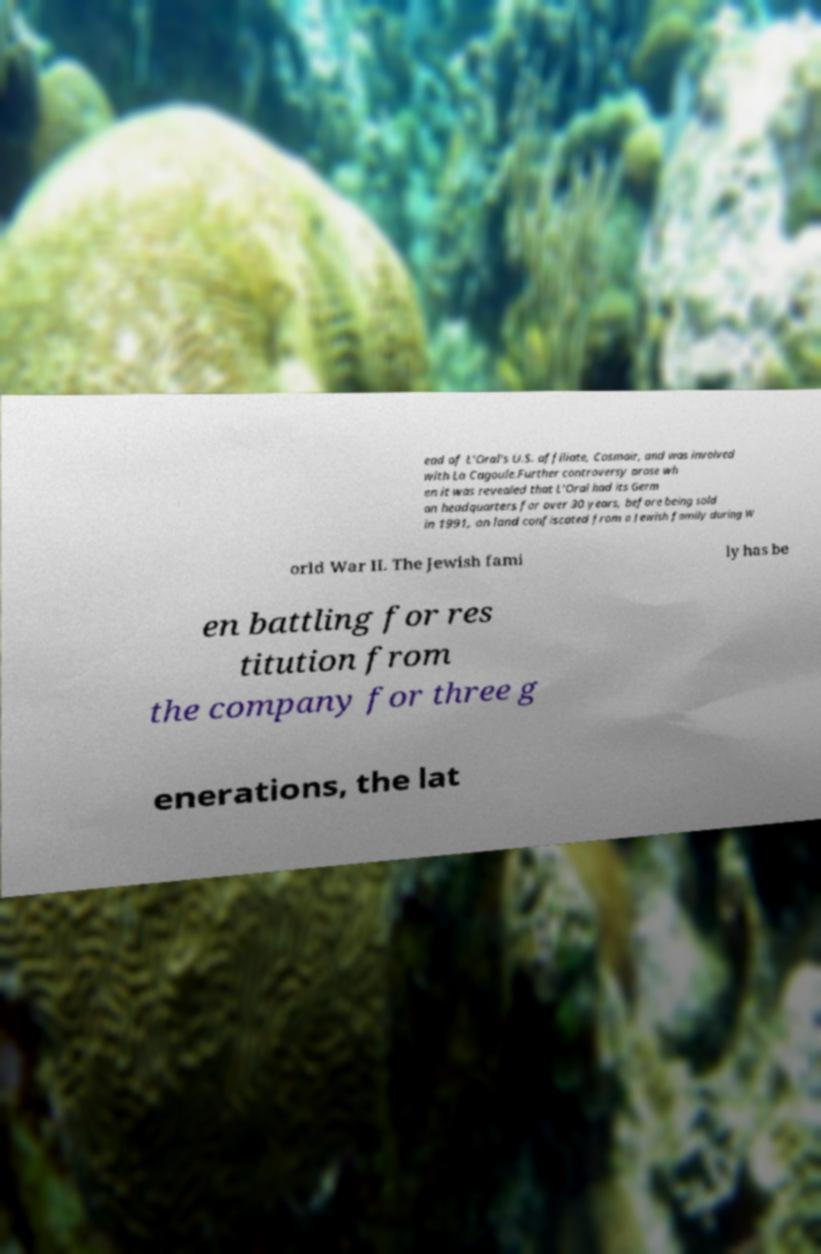Please identify and transcribe the text found in this image. ead of L'Oral's U.S. affiliate, Cosmair, and was involved with La Cagoule.Further controversy arose wh en it was revealed that L'Oral had its Germ an headquarters for over 30 years, before being sold in 1991, on land confiscated from a Jewish family during W orld War II. The Jewish fami ly has be en battling for res titution from the company for three g enerations, the lat 